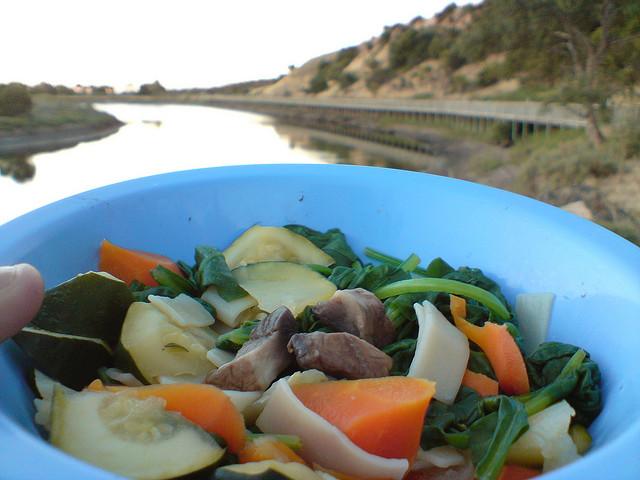What are the green items on the plate?
Be succinct. Spinach. Is the food in a plastic bowl?
Answer briefly. Yes. Does the dish contain any meat?
Concise answer only. Yes. What are the orange things?
Give a very brief answer. Carrots. Is the food oily?
Answer briefly. No. What three objects are blue?
Answer briefly. Bowl. What is this food?
Be succinct. Vegetables. What is the purple food on the plate?
Quick response, please. Mushrooms. Is this meal being served indoors?
Quick response, please. No. What are the green vegetables?
Keep it brief. Spinach. What is the green vegetable?
Be succinct. Spinach. What color is the plate?
Quick response, please. Blue. What color is the bowl?
Give a very brief answer. Blue. 